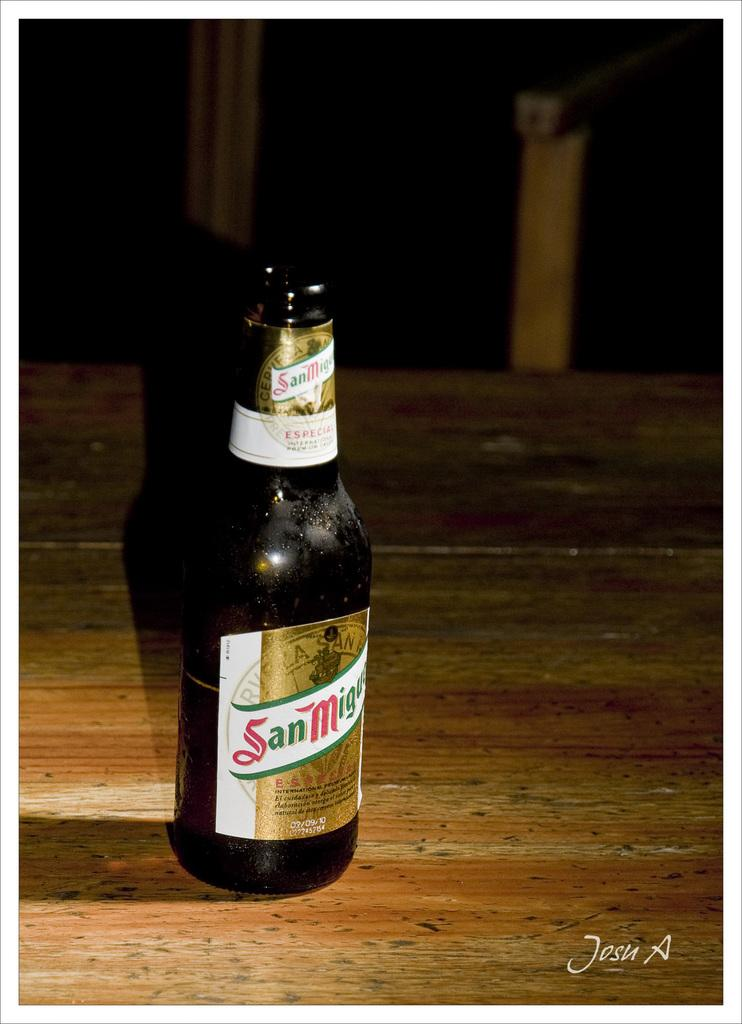<image>
Describe the image concisely. A bottle of beer on a table from San Miguel. 